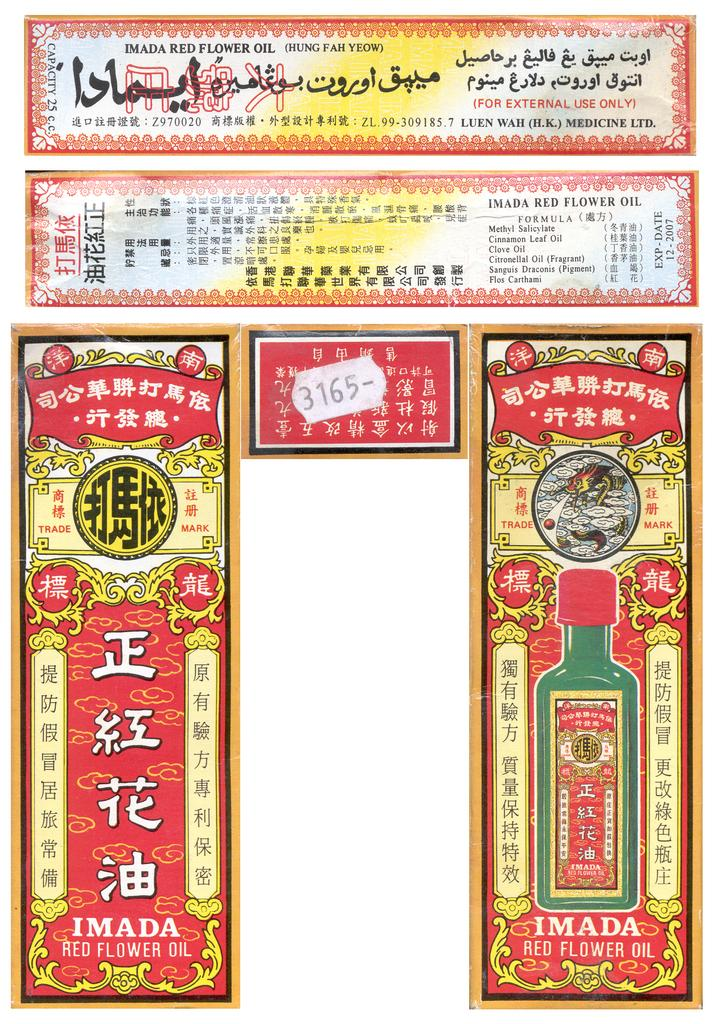Provide a one-sentence caption for the provided image. Imada Red Flower Oil is the header of this label. 